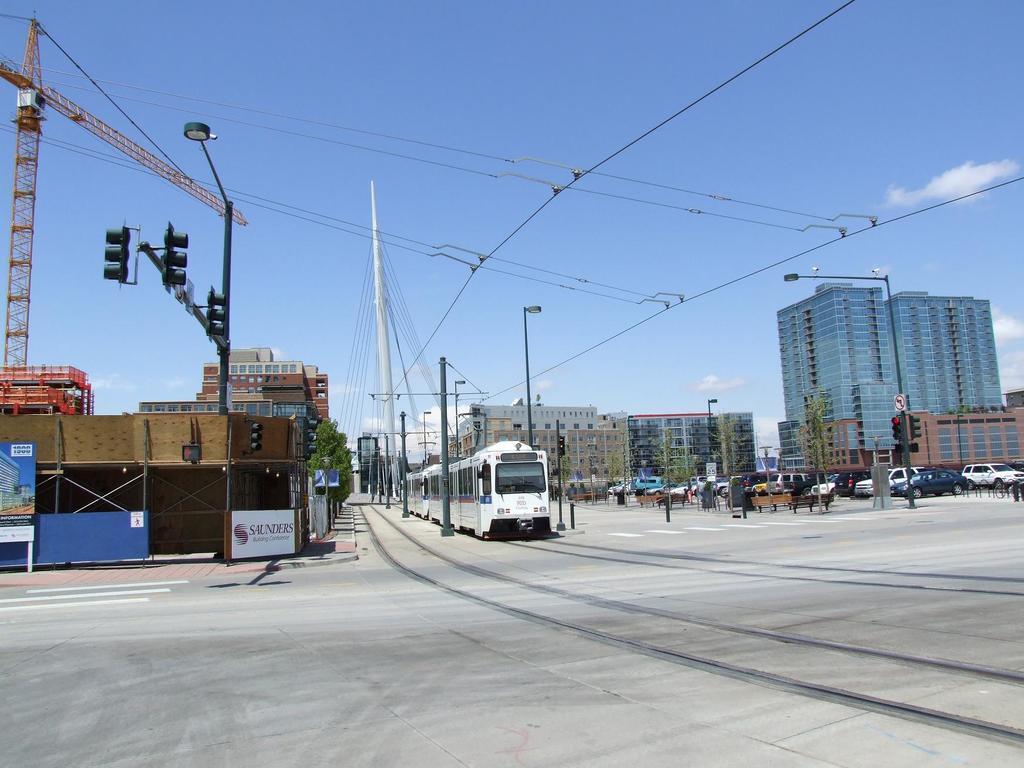Could you give a brief overview of what you see in this image? In the center of the image there is a train. In the background of the image there are buildings. At the bottom of the image there is road. There are traffic signals. There are street lights and electric wires. 